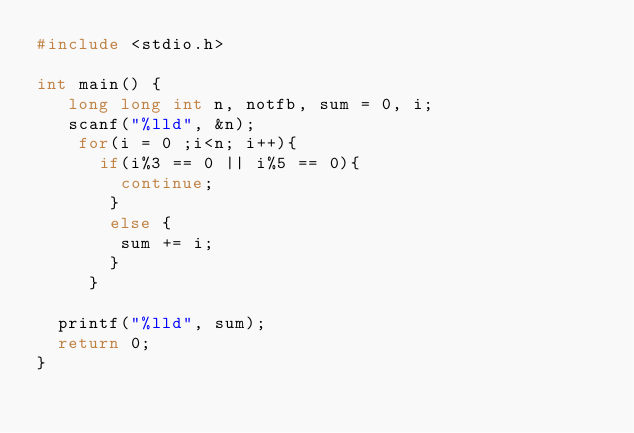<code> <loc_0><loc_0><loc_500><loc_500><_C++_>#include <stdio.h>

int main() {
	 long long int n, notfb, sum = 0, i;
	 scanf("%lld", &n);
	 	for(i = 0 ;i<n; i++){
	 		if(i%3 == 0 || i%5 == 0){
	 			continue;
			 }
			 else {
			 	sum += i;
			 }
		 }
	
	printf("%lld", sum);
	return 0;
}</code> 